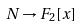Convert formula to latex. <formula><loc_0><loc_0><loc_500><loc_500>N \rightarrow F _ { 2 } [ x ]</formula> 